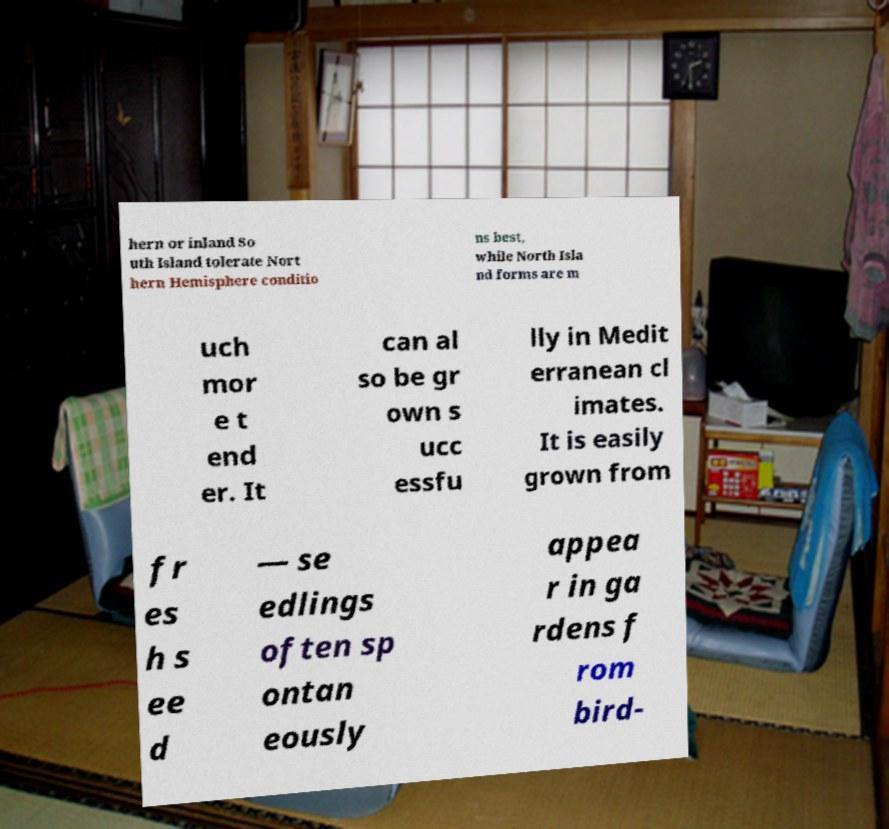There's text embedded in this image that I need extracted. Can you transcribe it verbatim? hern or inland So uth Island tolerate Nort hern Hemisphere conditio ns best, while North Isla nd forms are m uch mor e t end er. It can al so be gr own s ucc essfu lly in Medit erranean cl imates. It is easily grown from fr es h s ee d — se edlings often sp ontan eously appea r in ga rdens f rom bird- 